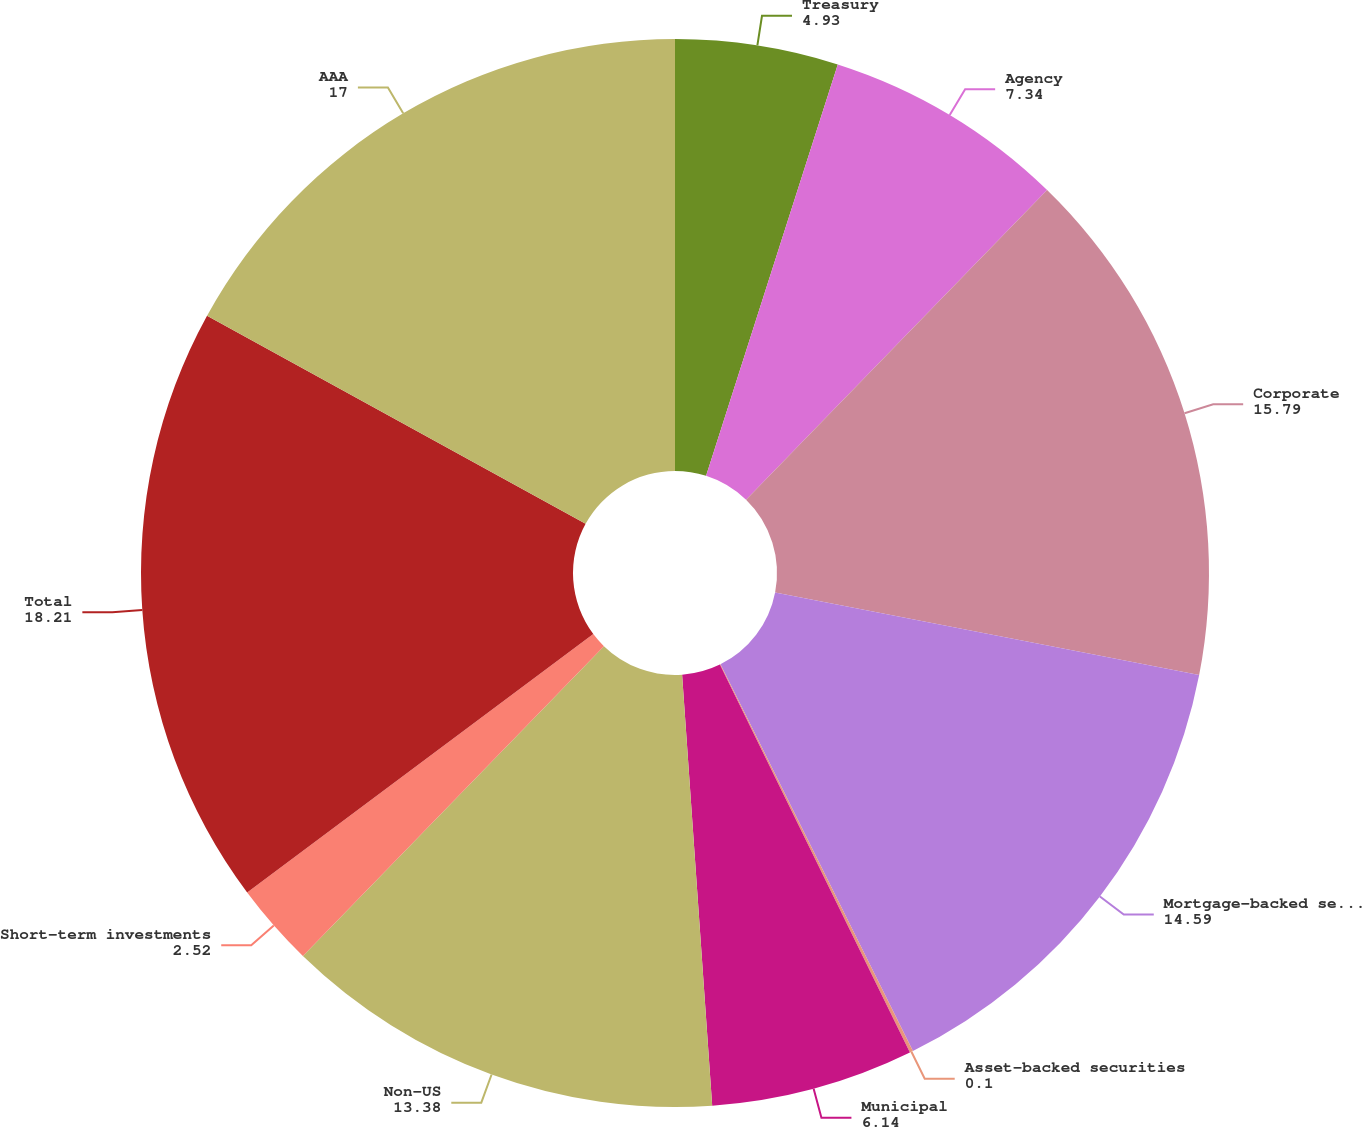Convert chart. <chart><loc_0><loc_0><loc_500><loc_500><pie_chart><fcel>Treasury<fcel>Agency<fcel>Corporate<fcel>Mortgage-backed securities<fcel>Asset-backed securities<fcel>Municipal<fcel>Non-US<fcel>Short-term investments<fcel>Total<fcel>AAA<nl><fcel>4.93%<fcel>7.34%<fcel>15.79%<fcel>14.59%<fcel>0.1%<fcel>6.14%<fcel>13.38%<fcel>2.52%<fcel>18.21%<fcel>17.0%<nl></chart> 